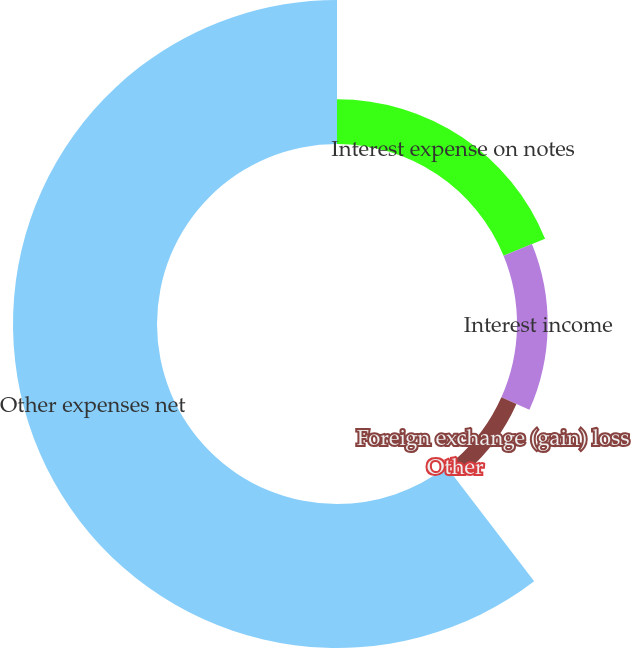<chart> <loc_0><loc_0><loc_500><loc_500><pie_chart><fcel>Interest expense on notes<fcel>Interest income<fcel>Foreign exchange (gain) loss<fcel>Other<fcel>Other expenses net<nl><fcel>18.81%<fcel>12.87%<fcel>6.93%<fcel>0.98%<fcel>60.41%<nl></chart> 